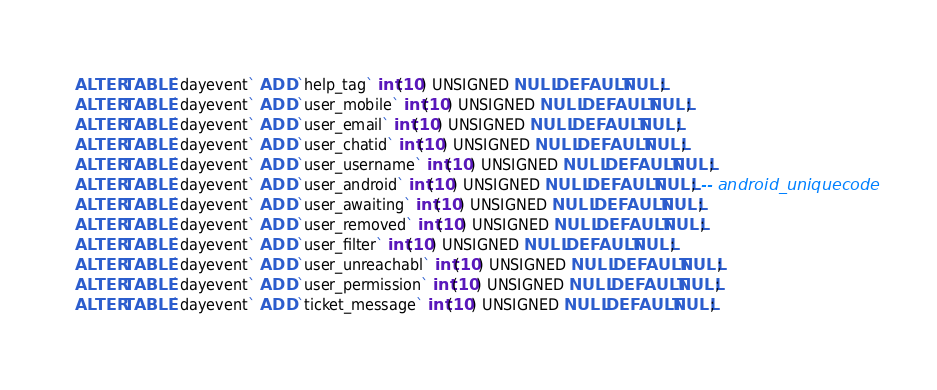<code> <loc_0><loc_0><loc_500><loc_500><_SQL_>ALTER TABLE `dayevent` ADD `help_tag` int(10) UNSIGNED NULL DEFAULT NULL;
ALTER TABLE `dayevent` ADD `user_mobile` int(10) UNSIGNED NULL DEFAULT NULL;
ALTER TABLE `dayevent` ADD `user_email` int(10) UNSIGNED NULL DEFAULT NULL;
ALTER TABLE `dayevent` ADD `user_chatid` int(10) UNSIGNED NULL DEFAULT NULL;
ALTER TABLE `dayevent` ADD `user_username` int(10) UNSIGNED NULL DEFAULT NULL;
ALTER TABLE `dayevent` ADD `user_android` int(10) UNSIGNED NULL DEFAULT NULL; -- android_uniquecode
ALTER TABLE `dayevent` ADD `user_awaiting` int(10) UNSIGNED NULL DEFAULT NULL;
ALTER TABLE `dayevent` ADD `user_removed` int(10) UNSIGNED NULL DEFAULT NULL;
ALTER TABLE `dayevent` ADD `user_filter` int(10) UNSIGNED NULL DEFAULT NULL;
ALTER TABLE `dayevent` ADD `user_unreachabl` int(10) UNSIGNED NULL DEFAULT NULL;
ALTER TABLE `dayevent` ADD `user_permission` int(10) UNSIGNED NULL DEFAULT NULL;
ALTER TABLE `dayevent` ADD `ticket_message` int(10) UNSIGNED NULL DEFAULT NULL;</code> 